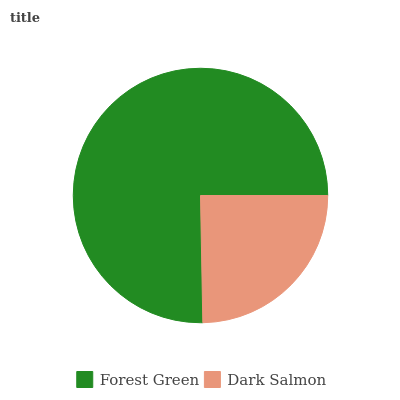Is Dark Salmon the minimum?
Answer yes or no. Yes. Is Forest Green the maximum?
Answer yes or no. Yes. Is Dark Salmon the maximum?
Answer yes or no. No. Is Forest Green greater than Dark Salmon?
Answer yes or no. Yes. Is Dark Salmon less than Forest Green?
Answer yes or no. Yes. Is Dark Salmon greater than Forest Green?
Answer yes or no. No. Is Forest Green less than Dark Salmon?
Answer yes or no. No. Is Forest Green the high median?
Answer yes or no. Yes. Is Dark Salmon the low median?
Answer yes or no. Yes. Is Dark Salmon the high median?
Answer yes or no. No. Is Forest Green the low median?
Answer yes or no. No. 